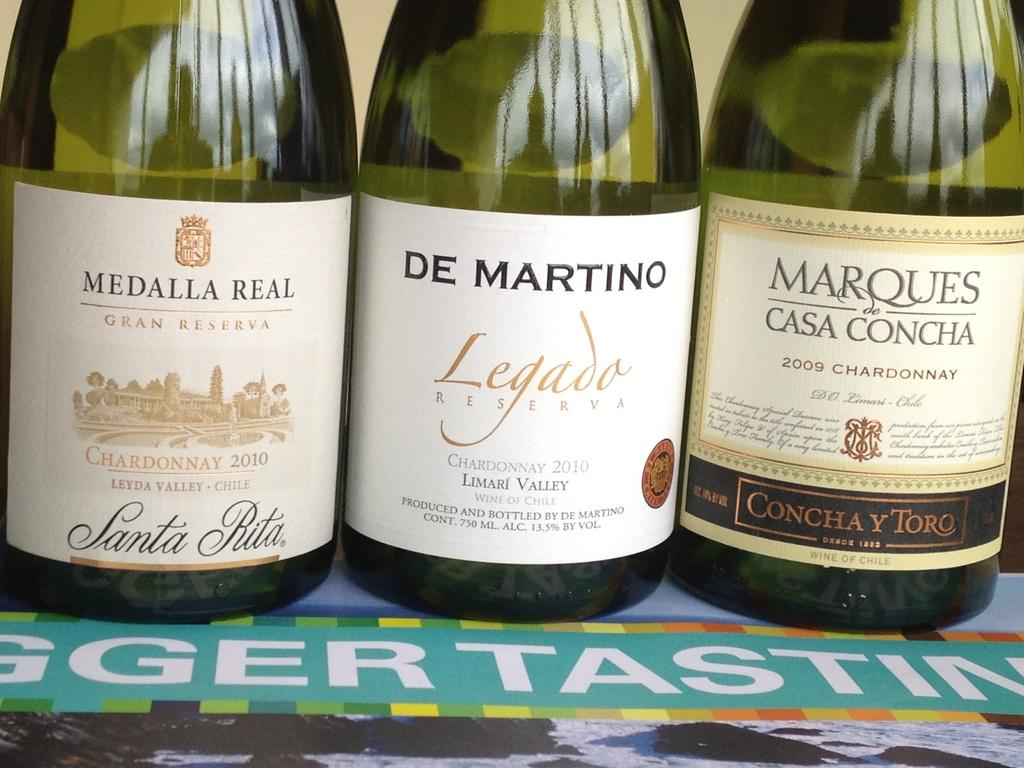<image>
Create a compact narrative representing the image presented. the name de martino that is on a bottle 